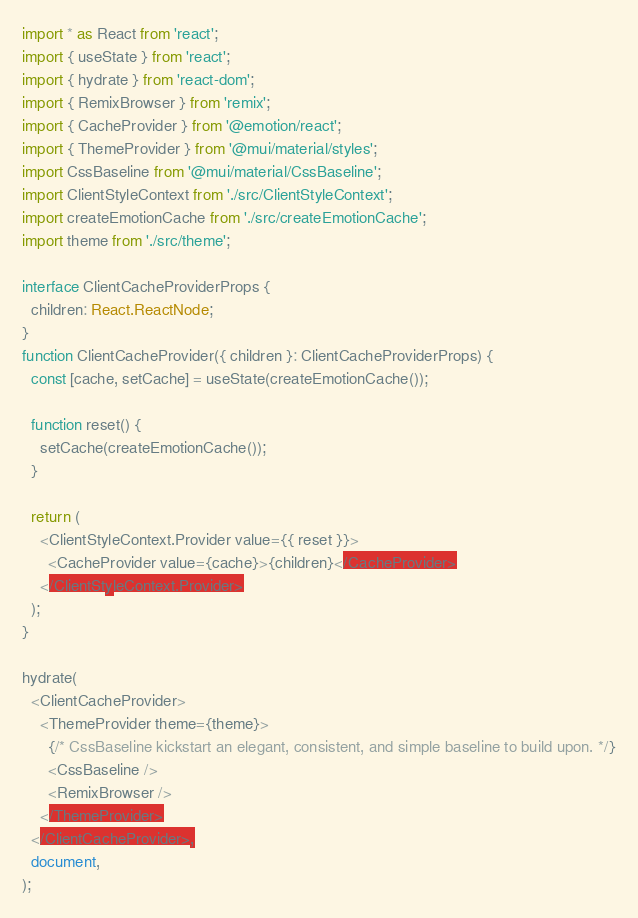Convert code to text. <code><loc_0><loc_0><loc_500><loc_500><_TypeScript_>import * as React from 'react';
import { useState } from 'react';
import { hydrate } from 'react-dom';
import { RemixBrowser } from 'remix';
import { CacheProvider } from '@emotion/react';
import { ThemeProvider } from '@mui/material/styles';
import CssBaseline from '@mui/material/CssBaseline';
import ClientStyleContext from './src/ClientStyleContext';
import createEmotionCache from './src/createEmotionCache';
import theme from './src/theme';

interface ClientCacheProviderProps {
  children: React.ReactNode;
}
function ClientCacheProvider({ children }: ClientCacheProviderProps) {
  const [cache, setCache] = useState(createEmotionCache());

  function reset() {
    setCache(createEmotionCache());
  }

  return (
    <ClientStyleContext.Provider value={{ reset }}>
      <CacheProvider value={cache}>{children}</CacheProvider>
    </ClientStyleContext.Provider>
  );
}

hydrate(
  <ClientCacheProvider>
    <ThemeProvider theme={theme}>
      {/* CssBaseline kickstart an elegant, consistent, and simple baseline to build upon. */}
      <CssBaseline />
      <RemixBrowser />
    </ThemeProvider>
  </ClientCacheProvider>,
  document,
);
</code> 